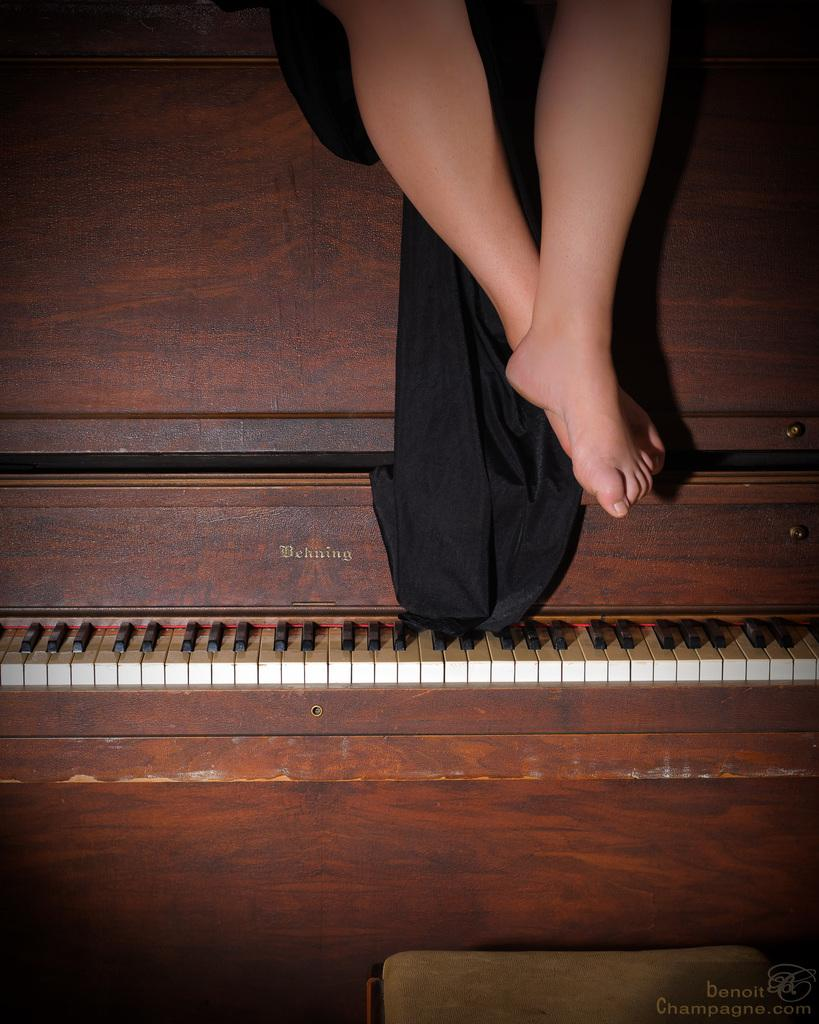What part of a person can be seen in the image? There are legs of a person in the image. What object is also present in the image? There is a piano in the image. What type of vein is visible on the person's legs in the image? There is no visible vein on the person's legs in the image. What health condition can be observed in the person's legs in the image? There is no health condition visible in the person's legs in the image. 